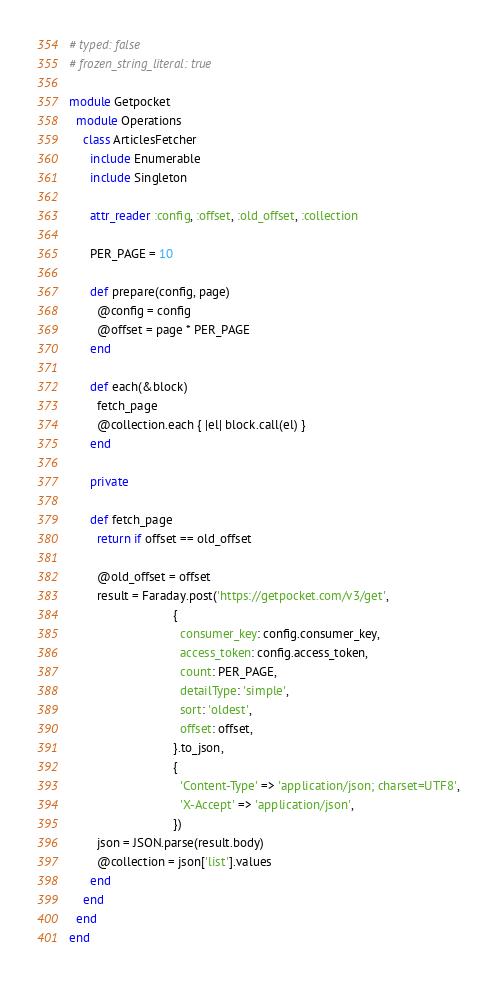Convert code to text. <code><loc_0><loc_0><loc_500><loc_500><_Ruby_># typed: false
# frozen_string_literal: true

module Getpocket
  module Operations
    class ArticlesFetcher
      include Enumerable
      include Singleton

      attr_reader :config, :offset, :old_offset, :collection

      PER_PAGE = 10

      def prepare(config, page)
        @config = config
        @offset = page * PER_PAGE
      end

      def each(&block)
        fetch_page
        @collection.each { |el| block.call(el) }
      end

      private

      def fetch_page
        return if offset == old_offset

        @old_offset = offset
        result = Faraday.post('https://getpocket.com/v3/get',
                              {
                                consumer_key: config.consumer_key,
                                access_token: config.access_token,
                                count: PER_PAGE,
                                detailType: 'simple',
                                sort: 'oldest',
                                offset: offset,
                              }.to_json,
                              {
                                'Content-Type' => 'application/json; charset=UTF8',
                                'X-Accept' => 'application/json',
                              })
        json = JSON.parse(result.body)
        @collection = json['list'].values
      end
    end
  end
end
</code> 